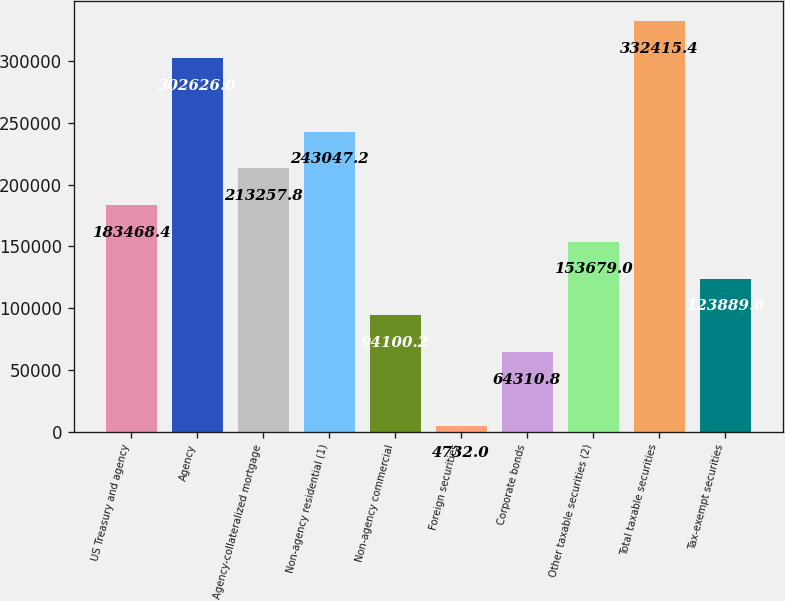Convert chart to OTSL. <chart><loc_0><loc_0><loc_500><loc_500><bar_chart><fcel>US Treasury and agency<fcel>Agency<fcel>Agency-collateralized mortgage<fcel>Non-agency residential (1)<fcel>Non-agency commercial<fcel>Foreign securities<fcel>Corporate bonds<fcel>Other taxable securities (2)<fcel>Total taxable securities<fcel>Tax-exempt securities<nl><fcel>183468<fcel>302626<fcel>213258<fcel>243047<fcel>94100.2<fcel>4732<fcel>64310.8<fcel>153679<fcel>332415<fcel>123890<nl></chart> 